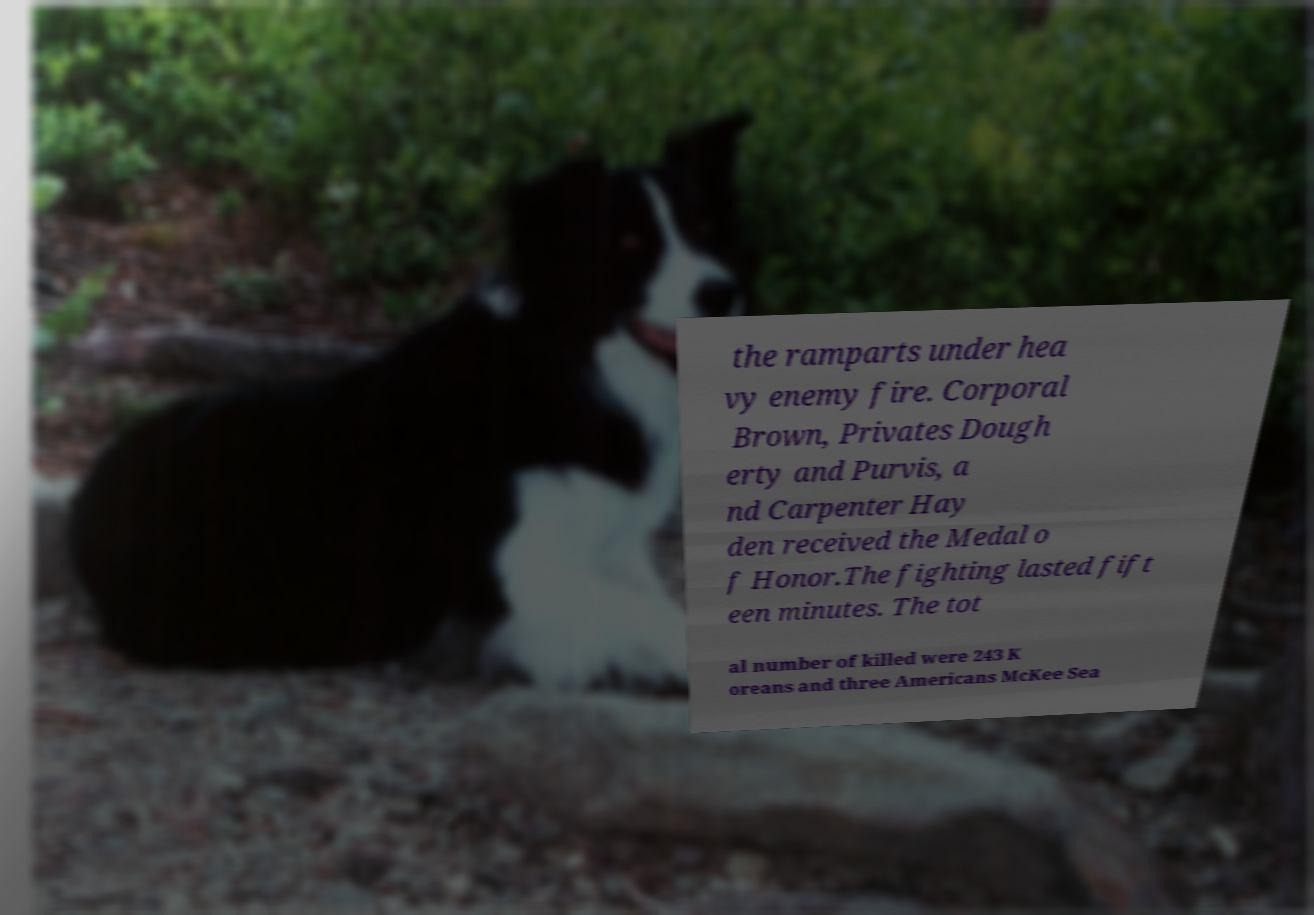Can you read and provide the text displayed in the image?This photo seems to have some interesting text. Can you extract and type it out for me? the ramparts under hea vy enemy fire. Corporal Brown, Privates Dough erty and Purvis, a nd Carpenter Hay den received the Medal o f Honor.The fighting lasted fift een minutes. The tot al number of killed were 243 K oreans and three Americans McKee Sea 